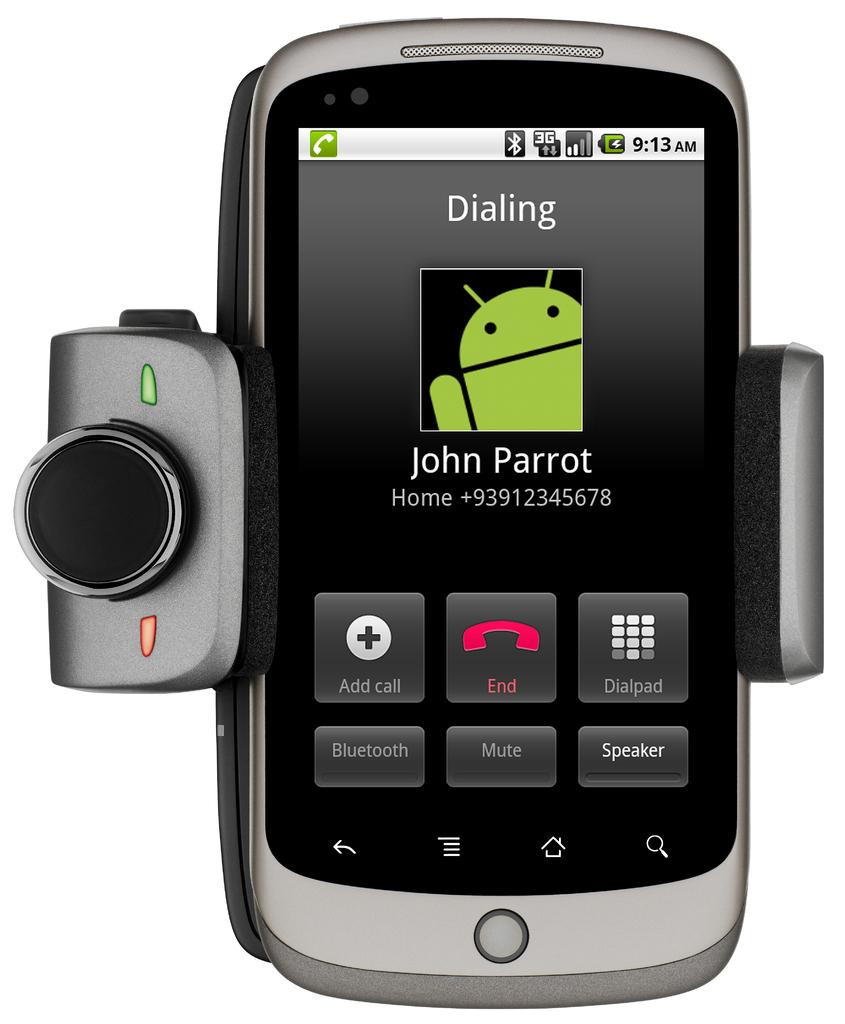<image>
Render a clear and concise summary of the photo. A phone that is dialing John Parrot and has no photo 